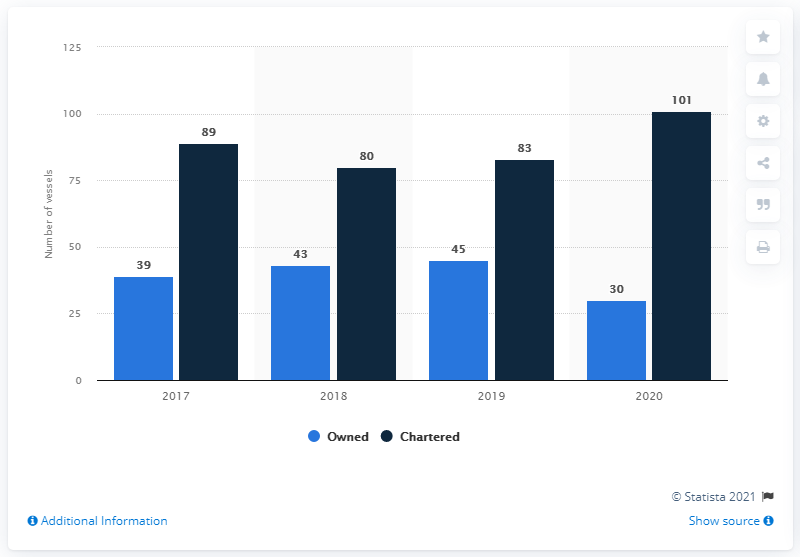Mention a couple of crucial points in this snapshot. The shortest dark blue bar and the longest light blue bar are 125 units each. Petrobras owned 30 vessels in 2020. In 2020, the discrepancy between the number of owned and chartered vessels was the largest. In 2020, Petrobras owned 101 chartered vessels. 